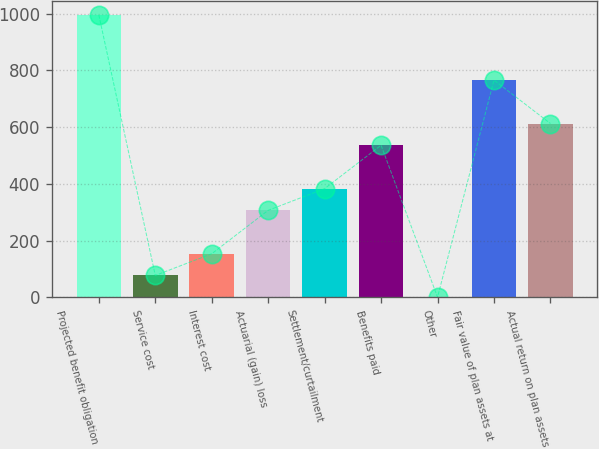Convert chart to OTSL. <chart><loc_0><loc_0><loc_500><loc_500><bar_chart><fcel>Projected benefit obligation<fcel>Service cost<fcel>Interest cost<fcel>Actuarial (gain) loss<fcel>Settlement/curtailment<fcel>Benefits paid<fcel>Other<fcel>Fair value of plan assets at<fcel>Actual return on plan assets<nl><fcel>995.21<fcel>77.57<fcel>154.04<fcel>306.98<fcel>383.45<fcel>536.39<fcel>1.1<fcel>765.8<fcel>612.86<nl></chart> 